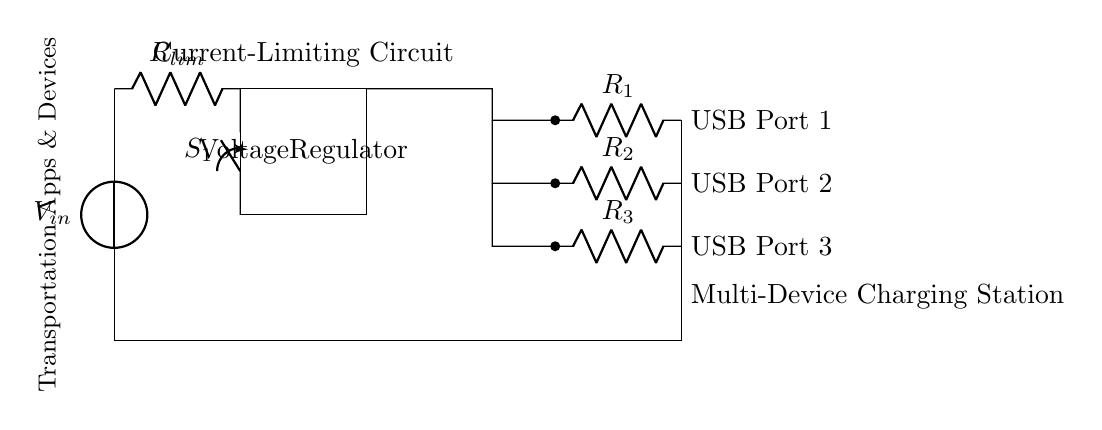What is the function of the resistor labeled R lim? The resistor R lim is a current-limiting resistor, which is used to prevent excessive current from flowing into the circuit, ensuring safe operation of the USB charging ports.
Answer: Current-limiting What type of component is labeled S1? The component labeled S1 is a closing switch, which can either allow or interrupt the flow of current in the circuit when toggled on or off.
Answer: Closing switch How many USB ports are shown in the circuit diagram? The diagram illustrates three USB ports, each connected with its own series resistor to manage current flow.
Answer: Three What is the purpose of the voltage regulator in this circuit? The voltage regulator stabilizes the output voltage to a fixed level, ensuring that the voltage supplied to the USB ports remains consistent and suitable for charging devices.
Answer: Stabilizes voltage If the current-limiting resistor has a resistance of 10 ohms, what happens if the input voltage is increased? Increasing the input voltage while the resistance remains constant will lead to a higher current according to Ohm's Law, which could potentially exceed the current limits for the USB ports and damage connected devices without proper regulation.
Answer: Higher current risk What is the total potential difference provided by the voltage source? The voltage source labeled V in the circuit is not given a specific value, but it typically represents the input voltage from an outlet or power supply; common values for USB charging are 5 volts.
Answer: Input voltage What is the significance of using different resistors R1, R2, and R3 for each USB port? Using different resistors for each USB port allows for tailored current limitation depending on the power requirements of different devices that may be connected to each port.
Answer: Tailored current limitation 